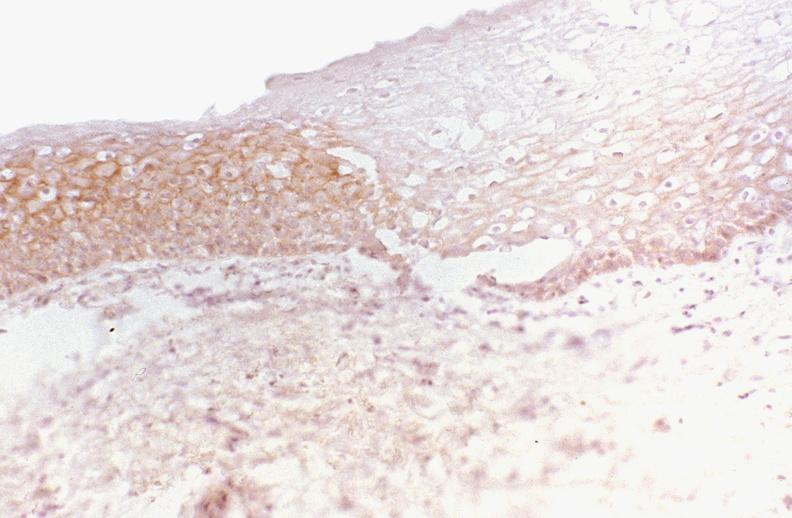does hemorrhage in newborn show oral dysplasia, neu?
Answer the question using a single word or phrase. No 